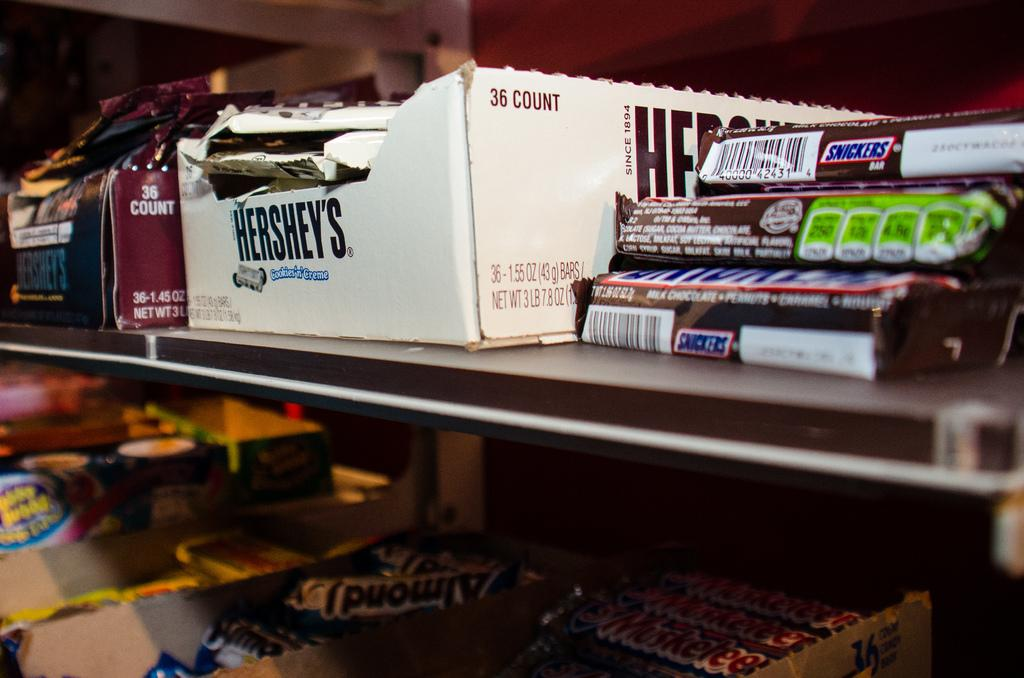<image>
Describe the image concisely. Boxes of candy including hersey's and snickers and almond joy 